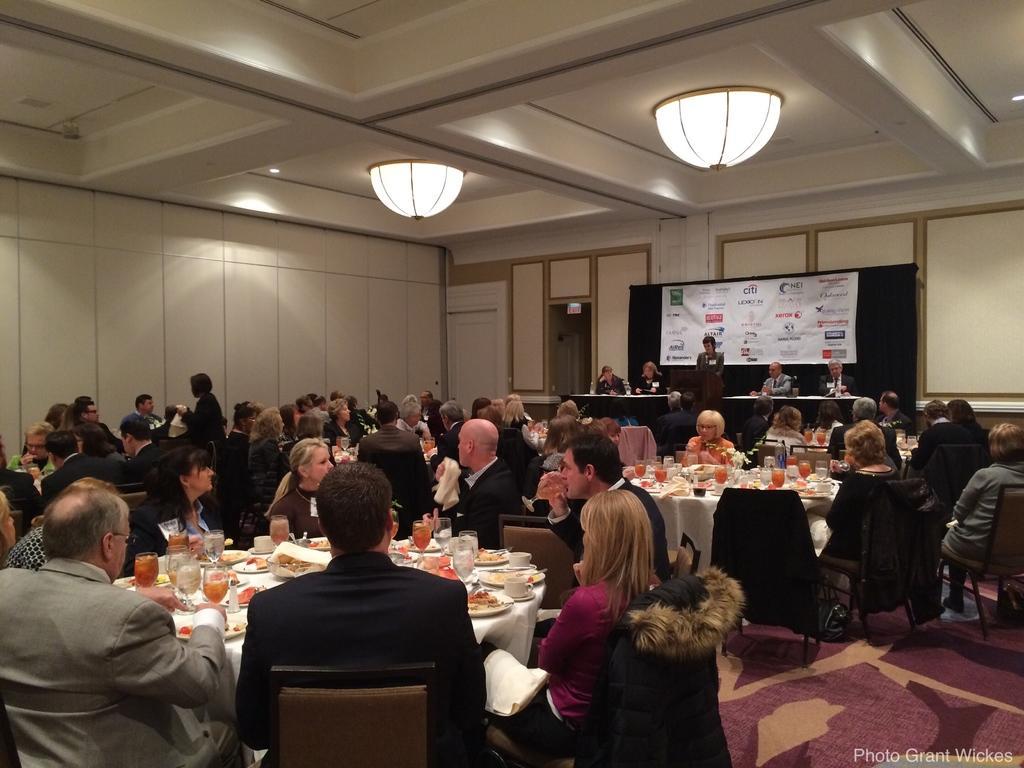Describe this image in one or two sentences. In this image I can see few persons sitting on the chairs. I can see few food items and drinks on the table. I can see a person standing. I can see a banner with some text on it. 